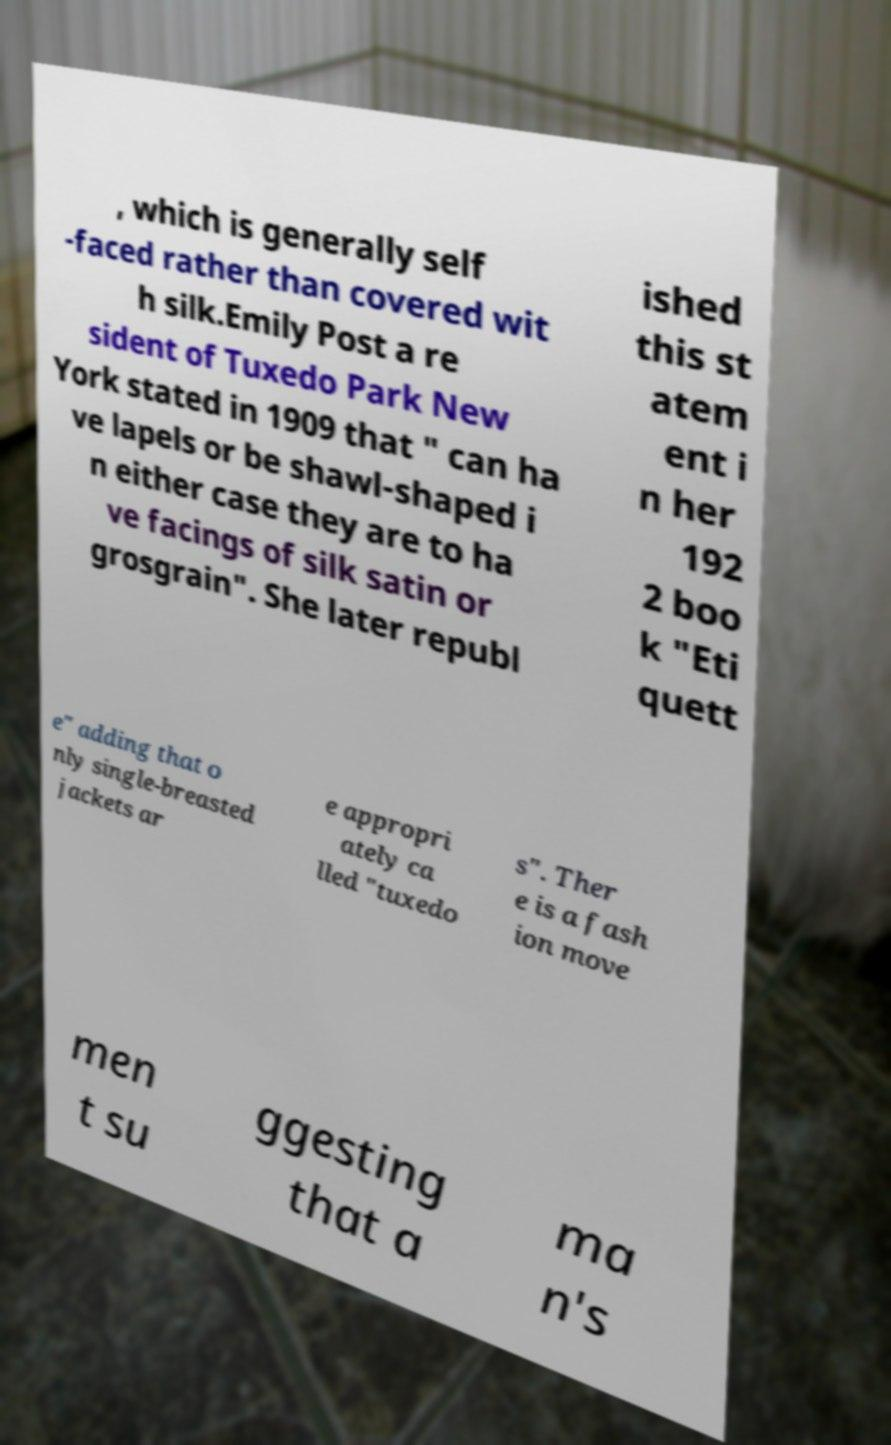I need the written content from this picture converted into text. Can you do that? , which is generally self -faced rather than covered wit h silk.Emily Post a re sident of Tuxedo Park New York stated in 1909 that " can ha ve lapels or be shawl-shaped i n either case they are to ha ve facings of silk satin or grosgrain". She later republ ished this st atem ent i n her 192 2 boo k "Eti quett e" adding that o nly single-breasted jackets ar e appropri ately ca lled "tuxedo s". Ther e is a fash ion move men t su ggesting that a ma n's 